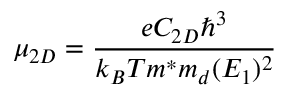<formula> <loc_0><loc_0><loc_500><loc_500>\mu _ { 2 D } = \frac { e C _ { 2 D } \hbar { ^ } { 3 } } { k _ { B } T m ^ { * } m _ { d } ( E _ { 1 } ) ^ { 2 } }</formula> 